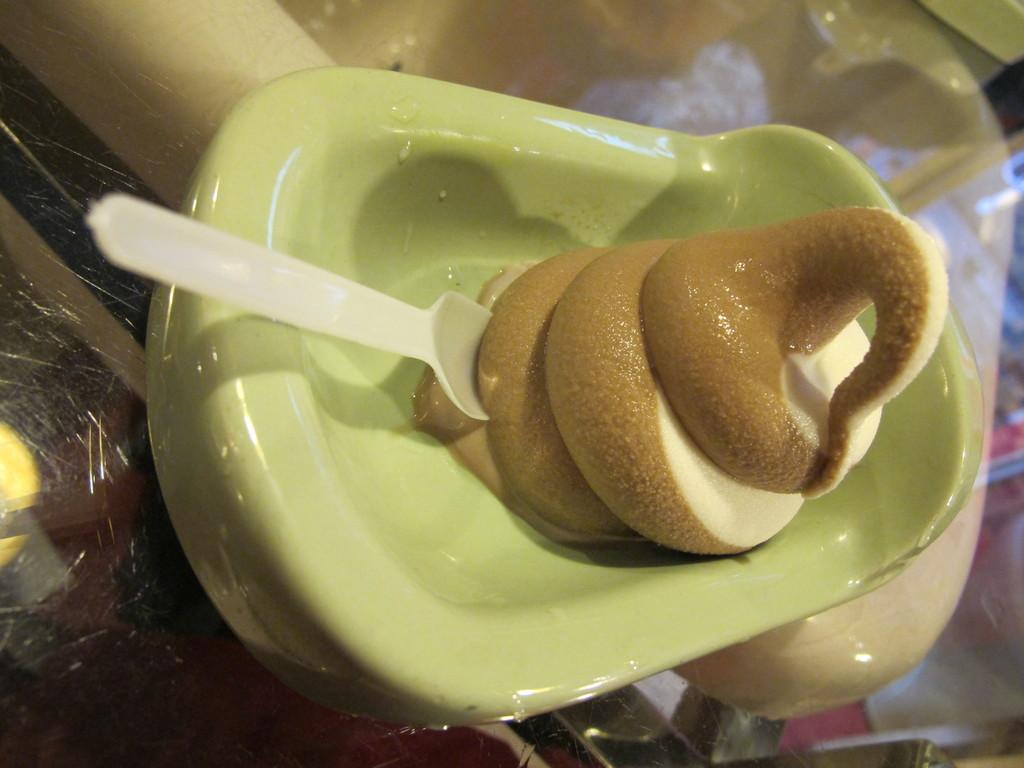What is in the bowl that is visible in the image? There is a bowl with ice cream in the image. What utensil is placed on the glass surface in the image? There is a spoon on the glass surface in the image. What can be seen on the glass surface in the image? Reflections are visible on the glass surface in the image. What objects can be seen through the glass surface in the image? Some objects are visible through the glass surface in the image. What type of nerve can be seen in the image? There is no nerve present in the image; it features a bowl of ice cream, a spoon, and a glass surface with reflections and visible objects. 